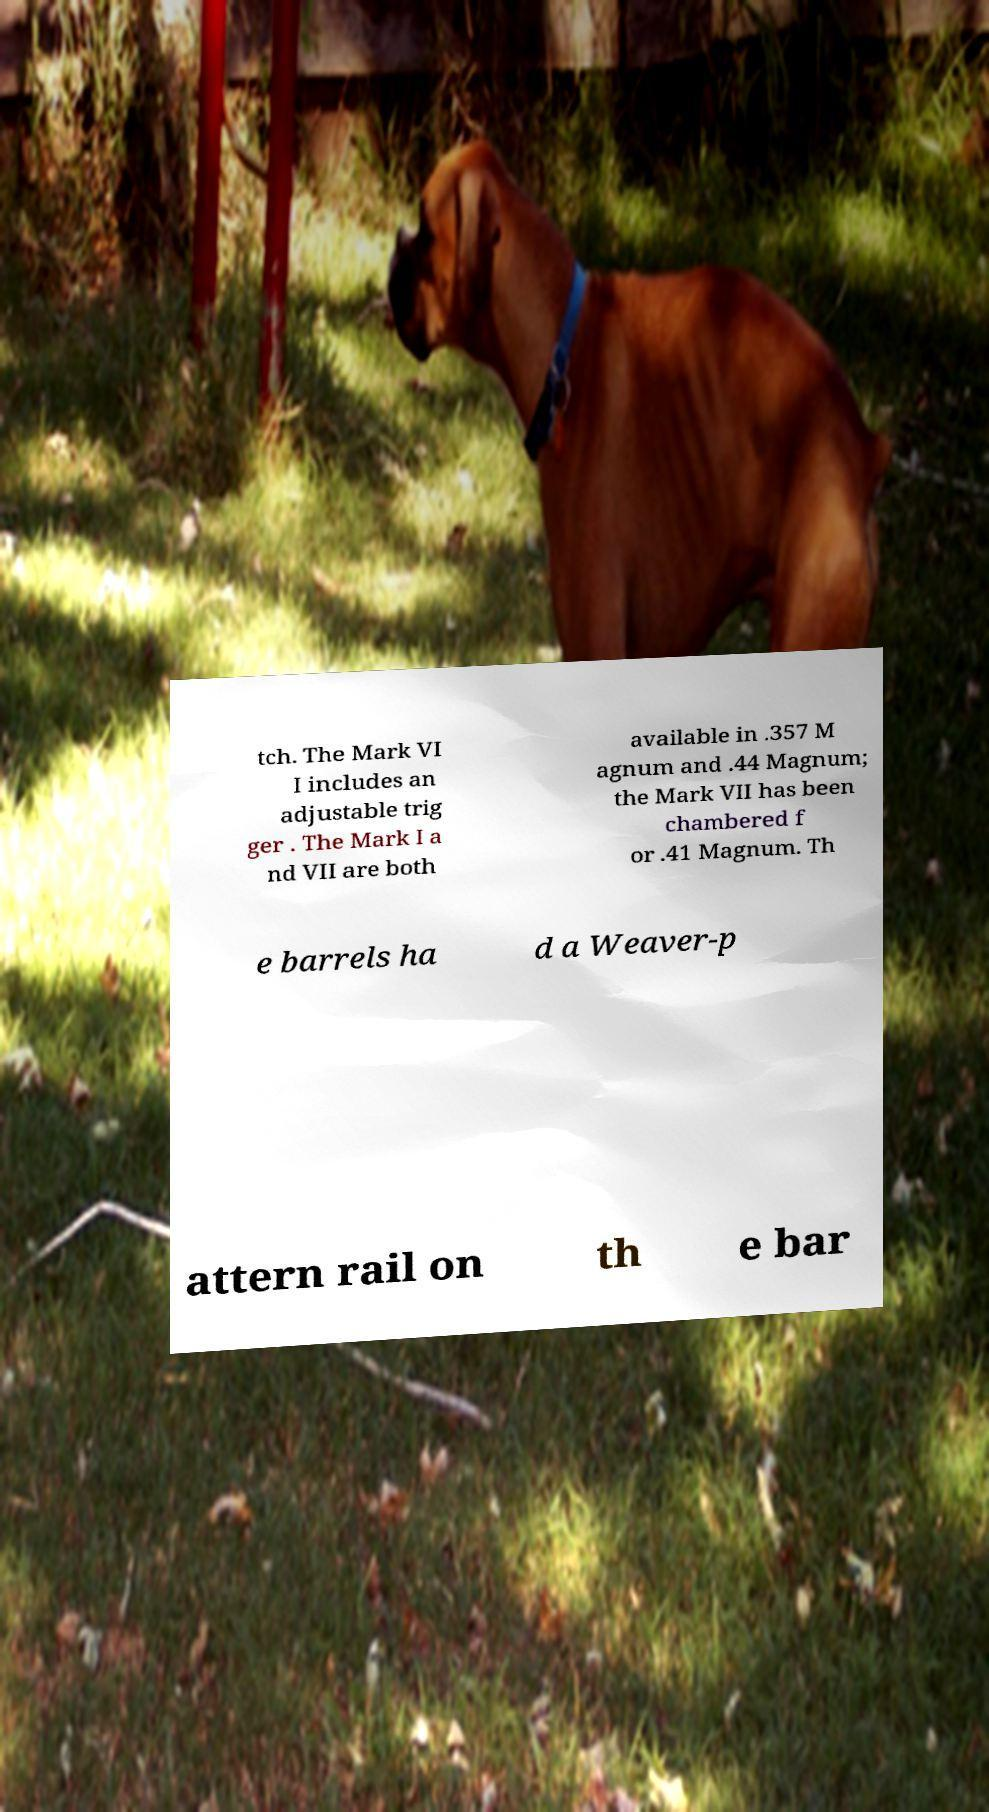I need the written content from this picture converted into text. Can you do that? tch. The Mark VI I includes an adjustable trig ger . The Mark I a nd VII are both available in .357 M agnum and .44 Magnum; the Mark VII has been chambered f or .41 Magnum. Th e barrels ha d a Weaver-p attern rail on th e bar 